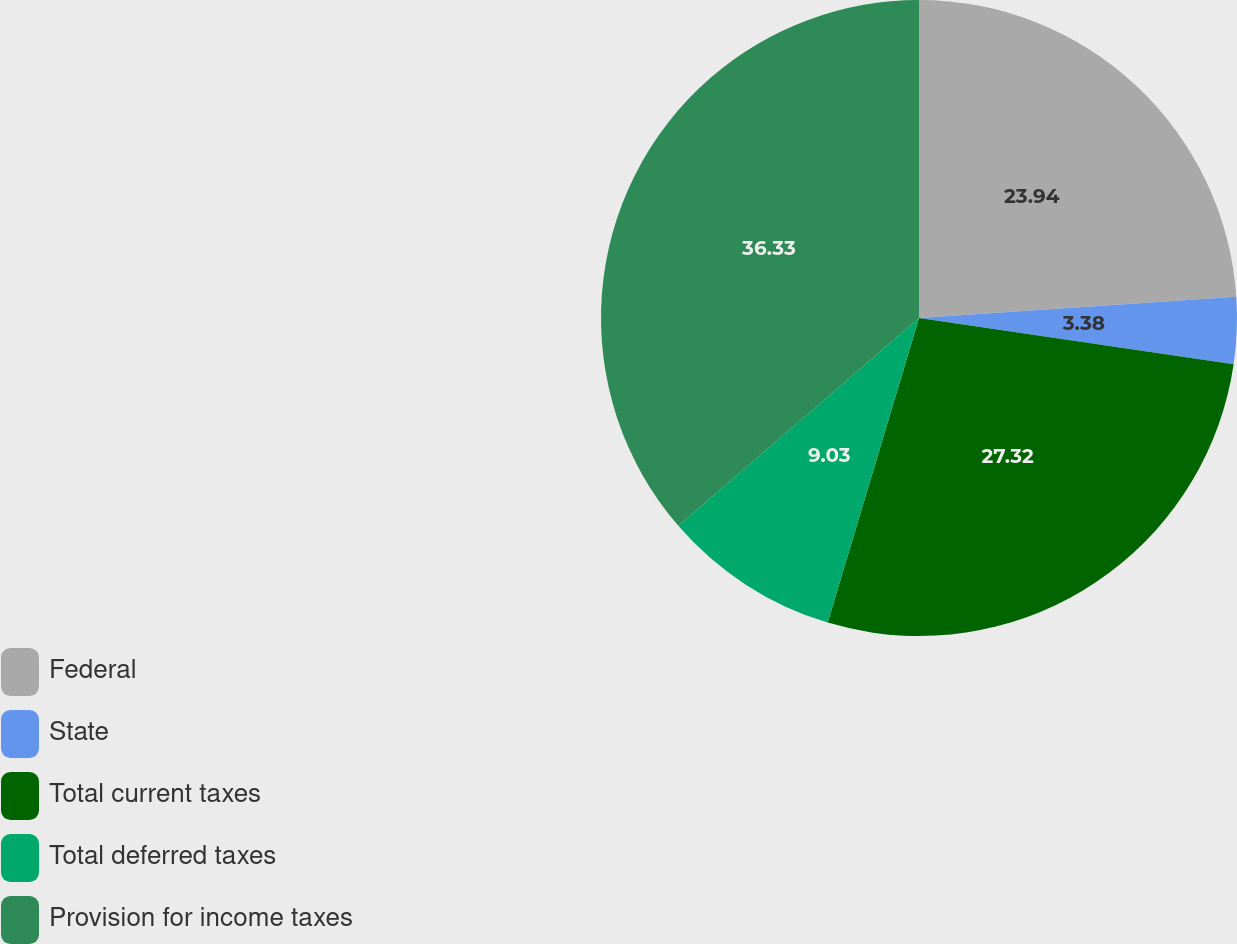Convert chart. <chart><loc_0><loc_0><loc_500><loc_500><pie_chart><fcel>Federal<fcel>State<fcel>Total current taxes<fcel>Total deferred taxes<fcel>Provision for income taxes<nl><fcel>23.94%<fcel>3.38%<fcel>27.32%<fcel>9.03%<fcel>36.34%<nl></chart> 